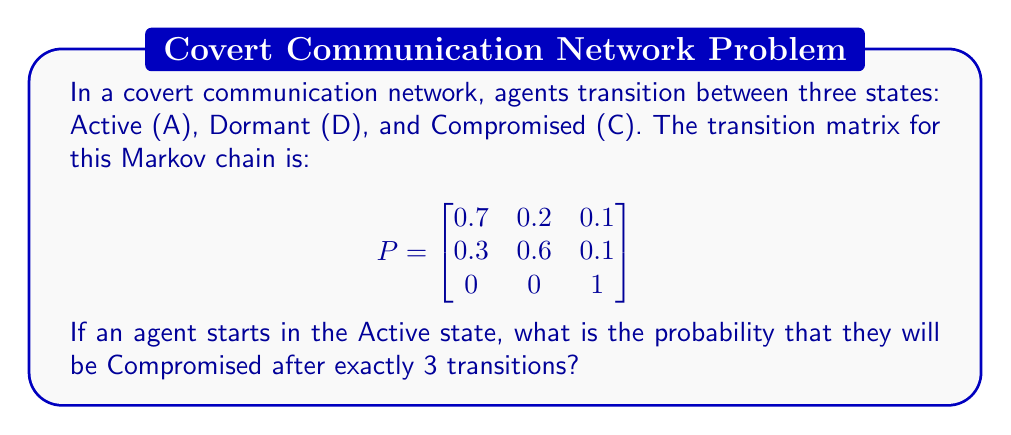Provide a solution to this math problem. To solve this problem, we need to calculate the 3-step transition probability from state A to state C. We can do this by raising the transition matrix P to the power of 3 and then looking at the element in the first row, third column.

Step 1: Calculate $P^3$
$$P^3 = P \times P \times P$$

Step 2: Perform matrix multiplication
$$
P^2 = \begin{bmatrix}
0.7 & 0.2 & 0.1 \\
0.3 & 0.6 & 0.1 \\
0 & 0 & 1
\end{bmatrix} \times 
\begin{bmatrix}
0.7 & 0.2 & 0.1 \\
0.3 & 0.6 & 0.1 \\
0 & 0 & 1
\end{bmatrix} = 
\begin{bmatrix}
0.58 & 0.28 & 0.14 \\
0.51 & 0.36 & 0.13 \\
0 & 0 & 1
\end{bmatrix}
$$

$$
P^3 = P^2 \times P = 
\begin{bmatrix}
0.58 & 0.28 & 0.14 \\
0.51 & 0.36 & 0.13 \\
0 & 0 & 1
\end{bmatrix} \times
\begin{bmatrix}
0.7 & 0.2 & 0.1 \\
0.3 & 0.6 & 0.1 \\
0 & 0 & 1
\end{bmatrix} = 
\begin{bmatrix}
0.497 & 0.308 & 0.195 \\
0.468 & 0.348 & 0.184 \\
0 & 0 & 1
\end{bmatrix}
$$

Step 3: Identify the probability of transitioning from A to C in 3 steps
The probability we're looking for is the element in the first row, third column of $P^3$, which is 0.195.
Answer: 0.195 